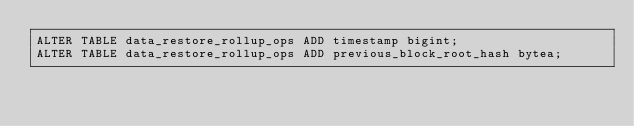<code> <loc_0><loc_0><loc_500><loc_500><_SQL_>ALTER TABLE data_restore_rollup_ops ADD timestamp bigint;
ALTER TABLE data_restore_rollup_ops ADD previous_block_root_hash bytea;

</code> 